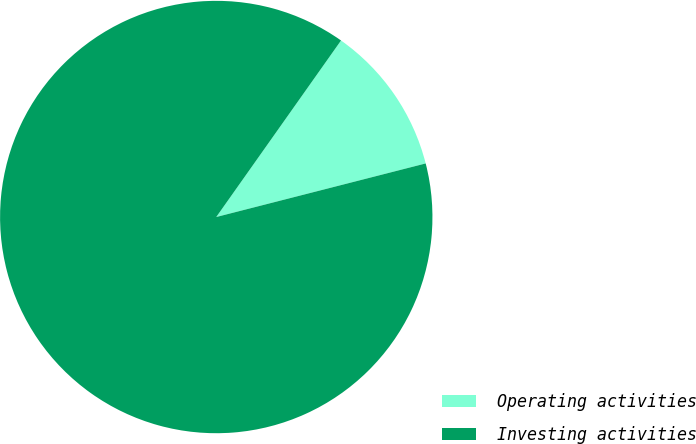Convert chart. <chart><loc_0><loc_0><loc_500><loc_500><pie_chart><fcel>Operating activities<fcel>Investing activities<nl><fcel>11.22%<fcel>88.78%<nl></chart> 